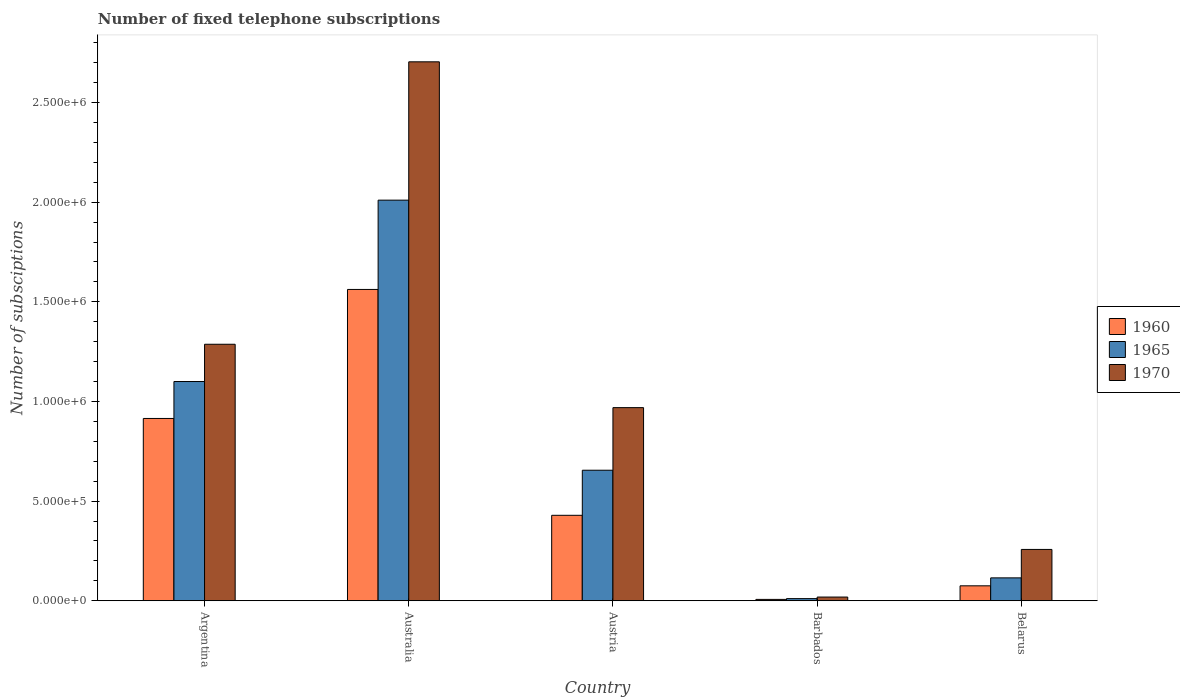How many different coloured bars are there?
Keep it short and to the point. 3. How many groups of bars are there?
Your response must be concise. 5. How many bars are there on the 1st tick from the right?
Make the answer very short. 3. What is the number of fixed telephone subscriptions in 1970 in Australia?
Keep it short and to the point. 2.70e+06. Across all countries, what is the maximum number of fixed telephone subscriptions in 1965?
Give a very brief answer. 2.01e+06. Across all countries, what is the minimum number of fixed telephone subscriptions in 1970?
Make the answer very short. 1.87e+04. In which country was the number of fixed telephone subscriptions in 1965 maximum?
Provide a succinct answer. Australia. In which country was the number of fixed telephone subscriptions in 1960 minimum?
Your answer should be compact. Barbados. What is the total number of fixed telephone subscriptions in 1970 in the graph?
Ensure brevity in your answer.  5.24e+06. What is the difference between the number of fixed telephone subscriptions in 1960 in Australia and that in Austria?
Your response must be concise. 1.13e+06. What is the difference between the number of fixed telephone subscriptions in 1970 in Austria and the number of fixed telephone subscriptions in 1965 in Australia?
Your answer should be compact. -1.04e+06. What is the average number of fixed telephone subscriptions in 1965 per country?
Offer a terse response. 7.78e+05. What is the difference between the number of fixed telephone subscriptions of/in 1965 and number of fixed telephone subscriptions of/in 1960 in Belarus?
Give a very brief answer. 3.99e+04. What is the ratio of the number of fixed telephone subscriptions in 1970 in Argentina to that in Barbados?
Your response must be concise. 68.89. Is the number of fixed telephone subscriptions in 1970 in Austria less than that in Barbados?
Make the answer very short. No. Is the difference between the number of fixed telephone subscriptions in 1965 in Barbados and Belarus greater than the difference between the number of fixed telephone subscriptions in 1960 in Barbados and Belarus?
Give a very brief answer. No. What is the difference between the highest and the second highest number of fixed telephone subscriptions in 1965?
Offer a terse response. 9.10e+05. What is the difference between the highest and the lowest number of fixed telephone subscriptions in 1960?
Your response must be concise. 1.56e+06. Is the sum of the number of fixed telephone subscriptions in 1965 in Argentina and Australia greater than the maximum number of fixed telephone subscriptions in 1960 across all countries?
Give a very brief answer. Yes. What does the 3rd bar from the left in Austria represents?
Offer a terse response. 1970. What does the 1st bar from the right in Argentina represents?
Give a very brief answer. 1970. Is it the case that in every country, the sum of the number of fixed telephone subscriptions in 1960 and number of fixed telephone subscriptions in 1970 is greater than the number of fixed telephone subscriptions in 1965?
Provide a short and direct response. Yes. Are all the bars in the graph horizontal?
Keep it short and to the point. No. Does the graph contain any zero values?
Your response must be concise. No. Where does the legend appear in the graph?
Your answer should be very brief. Center right. How many legend labels are there?
Provide a succinct answer. 3. How are the legend labels stacked?
Your answer should be very brief. Vertical. What is the title of the graph?
Provide a short and direct response. Number of fixed telephone subscriptions. Does "2006" appear as one of the legend labels in the graph?
Provide a succinct answer. No. What is the label or title of the X-axis?
Provide a succinct answer. Country. What is the label or title of the Y-axis?
Keep it short and to the point. Number of subsciptions. What is the Number of subsciptions in 1960 in Argentina?
Provide a short and direct response. 9.15e+05. What is the Number of subsciptions in 1965 in Argentina?
Your response must be concise. 1.10e+06. What is the Number of subsciptions of 1970 in Argentina?
Offer a terse response. 1.29e+06. What is the Number of subsciptions of 1960 in Australia?
Give a very brief answer. 1.56e+06. What is the Number of subsciptions of 1965 in Australia?
Your answer should be very brief. 2.01e+06. What is the Number of subsciptions of 1970 in Australia?
Your response must be concise. 2.70e+06. What is the Number of subsciptions in 1960 in Austria?
Offer a terse response. 4.29e+05. What is the Number of subsciptions in 1965 in Austria?
Provide a short and direct response. 6.55e+05. What is the Number of subsciptions in 1970 in Austria?
Offer a terse response. 9.69e+05. What is the Number of subsciptions of 1960 in Barbados?
Give a very brief answer. 6933. What is the Number of subsciptions of 1965 in Barbados?
Offer a very short reply. 1.08e+04. What is the Number of subsciptions in 1970 in Barbados?
Your answer should be very brief. 1.87e+04. What is the Number of subsciptions in 1960 in Belarus?
Your response must be concise. 7.50e+04. What is the Number of subsciptions of 1965 in Belarus?
Keep it short and to the point. 1.15e+05. What is the Number of subsciptions of 1970 in Belarus?
Your answer should be compact. 2.58e+05. Across all countries, what is the maximum Number of subsciptions of 1960?
Provide a succinct answer. 1.56e+06. Across all countries, what is the maximum Number of subsciptions of 1965?
Your answer should be very brief. 2.01e+06. Across all countries, what is the maximum Number of subsciptions of 1970?
Give a very brief answer. 2.70e+06. Across all countries, what is the minimum Number of subsciptions in 1960?
Provide a short and direct response. 6933. Across all countries, what is the minimum Number of subsciptions in 1965?
Provide a short and direct response. 1.08e+04. Across all countries, what is the minimum Number of subsciptions of 1970?
Offer a terse response. 1.87e+04. What is the total Number of subsciptions in 1960 in the graph?
Keep it short and to the point. 2.99e+06. What is the total Number of subsciptions in 1965 in the graph?
Provide a short and direct response. 3.89e+06. What is the total Number of subsciptions of 1970 in the graph?
Provide a short and direct response. 5.24e+06. What is the difference between the Number of subsciptions in 1960 in Argentina and that in Australia?
Make the answer very short. -6.47e+05. What is the difference between the Number of subsciptions of 1965 in Argentina and that in Australia?
Your answer should be very brief. -9.10e+05. What is the difference between the Number of subsciptions of 1970 in Argentina and that in Australia?
Give a very brief answer. -1.42e+06. What is the difference between the Number of subsciptions in 1960 in Argentina and that in Austria?
Give a very brief answer. 4.86e+05. What is the difference between the Number of subsciptions in 1965 in Argentina and that in Austria?
Ensure brevity in your answer.  4.45e+05. What is the difference between the Number of subsciptions of 1970 in Argentina and that in Austria?
Offer a very short reply. 3.18e+05. What is the difference between the Number of subsciptions of 1960 in Argentina and that in Barbados?
Keep it short and to the point. 9.08e+05. What is the difference between the Number of subsciptions of 1965 in Argentina and that in Barbados?
Give a very brief answer. 1.09e+06. What is the difference between the Number of subsciptions of 1970 in Argentina and that in Barbados?
Offer a terse response. 1.27e+06. What is the difference between the Number of subsciptions in 1960 in Argentina and that in Belarus?
Offer a terse response. 8.40e+05. What is the difference between the Number of subsciptions of 1965 in Argentina and that in Belarus?
Your answer should be very brief. 9.85e+05. What is the difference between the Number of subsciptions in 1970 in Argentina and that in Belarus?
Provide a short and direct response. 1.03e+06. What is the difference between the Number of subsciptions of 1960 in Australia and that in Austria?
Ensure brevity in your answer.  1.13e+06. What is the difference between the Number of subsciptions of 1965 in Australia and that in Austria?
Provide a short and direct response. 1.36e+06. What is the difference between the Number of subsciptions of 1970 in Australia and that in Austria?
Your answer should be very brief. 1.74e+06. What is the difference between the Number of subsciptions in 1960 in Australia and that in Barbados?
Provide a short and direct response. 1.56e+06. What is the difference between the Number of subsciptions of 1965 in Australia and that in Barbados?
Keep it short and to the point. 2.00e+06. What is the difference between the Number of subsciptions in 1970 in Australia and that in Barbados?
Your answer should be very brief. 2.69e+06. What is the difference between the Number of subsciptions of 1960 in Australia and that in Belarus?
Provide a succinct answer. 1.49e+06. What is the difference between the Number of subsciptions of 1965 in Australia and that in Belarus?
Offer a terse response. 1.90e+06. What is the difference between the Number of subsciptions in 1970 in Australia and that in Belarus?
Give a very brief answer. 2.45e+06. What is the difference between the Number of subsciptions of 1960 in Austria and that in Barbados?
Your response must be concise. 4.22e+05. What is the difference between the Number of subsciptions in 1965 in Austria and that in Barbados?
Give a very brief answer. 6.44e+05. What is the difference between the Number of subsciptions in 1970 in Austria and that in Barbados?
Keep it short and to the point. 9.50e+05. What is the difference between the Number of subsciptions of 1960 in Austria and that in Belarus?
Make the answer very short. 3.54e+05. What is the difference between the Number of subsciptions in 1965 in Austria and that in Belarus?
Make the answer very short. 5.40e+05. What is the difference between the Number of subsciptions in 1970 in Austria and that in Belarus?
Your response must be concise. 7.11e+05. What is the difference between the Number of subsciptions in 1960 in Barbados and that in Belarus?
Your answer should be compact. -6.81e+04. What is the difference between the Number of subsciptions in 1965 in Barbados and that in Belarus?
Make the answer very short. -1.04e+05. What is the difference between the Number of subsciptions of 1970 in Barbados and that in Belarus?
Make the answer very short. -2.39e+05. What is the difference between the Number of subsciptions of 1960 in Argentina and the Number of subsciptions of 1965 in Australia?
Your answer should be very brief. -1.10e+06. What is the difference between the Number of subsciptions of 1960 in Argentina and the Number of subsciptions of 1970 in Australia?
Provide a short and direct response. -1.79e+06. What is the difference between the Number of subsciptions of 1965 in Argentina and the Number of subsciptions of 1970 in Australia?
Provide a short and direct response. -1.60e+06. What is the difference between the Number of subsciptions of 1960 in Argentina and the Number of subsciptions of 1965 in Austria?
Your answer should be compact. 2.60e+05. What is the difference between the Number of subsciptions in 1960 in Argentina and the Number of subsciptions in 1970 in Austria?
Your answer should be compact. -5.43e+04. What is the difference between the Number of subsciptions in 1965 in Argentina and the Number of subsciptions in 1970 in Austria?
Ensure brevity in your answer.  1.31e+05. What is the difference between the Number of subsciptions of 1960 in Argentina and the Number of subsciptions of 1965 in Barbados?
Make the answer very short. 9.04e+05. What is the difference between the Number of subsciptions in 1960 in Argentina and the Number of subsciptions in 1970 in Barbados?
Make the answer very short. 8.96e+05. What is the difference between the Number of subsciptions in 1965 in Argentina and the Number of subsciptions in 1970 in Barbados?
Offer a terse response. 1.08e+06. What is the difference between the Number of subsciptions in 1960 in Argentina and the Number of subsciptions in 1965 in Belarus?
Make the answer very short. 8.00e+05. What is the difference between the Number of subsciptions of 1960 in Argentina and the Number of subsciptions of 1970 in Belarus?
Offer a terse response. 6.57e+05. What is the difference between the Number of subsciptions in 1965 in Argentina and the Number of subsciptions in 1970 in Belarus?
Offer a very short reply. 8.42e+05. What is the difference between the Number of subsciptions in 1960 in Australia and the Number of subsciptions in 1965 in Austria?
Your answer should be compact. 9.07e+05. What is the difference between the Number of subsciptions of 1960 in Australia and the Number of subsciptions of 1970 in Austria?
Your answer should be compact. 5.93e+05. What is the difference between the Number of subsciptions of 1965 in Australia and the Number of subsciptions of 1970 in Austria?
Provide a short and direct response. 1.04e+06. What is the difference between the Number of subsciptions in 1960 in Australia and the Number of subsciptions in 1965 in Barbados?
Make the answer very short. 1.55e+06. What is the difference between the Number of subsciptions of 1960 in Australia and the Number of subsciptions of 1970 in Barbados?
Offer a very short reply. 1.54e+06. What is the difference between the Number of subsciptions of 1965 in Australia and the Number of subsciptions of 1970 in Barbados?
Your answer should be compact. 1.99e+06. What is the difference between the Number of subsciptions in 1960 in Australia and the Number of subsciptions in 1965 in Belarus?
Ensure brevity in your answer.  1.45e+06. What is the difference between the Number of subsciptions in 1960 in Australia and the Number of subsciptions in 1970 in Belarus?
Keep it short and to the point. 1.30e+06. What is the difference between the Number of subsciptions in 1965 in Australia and the Number of subsciptions in 1970 in Belarus?
Offer a terse response. 1.75e+06. What is the difference between the Number of subsciptions in 1960 in Austria and the Number of subsciptions in 1965 in Barbados?
Ensure brevity in your answer.  4.18e+05. What is the difference between the Number of subsciptions of 1960 in Austria and the Number of subsciptions of 1970 in Barbados?
Ensure brevity in your answer.  4.10e+05. What is the difference between the Number of subsciptions of 1965 in Austria and the Number of subsciptions of 1970 in Barbados?
Provide a succinct answer. 6.36e+05. What is the difference between the Number of subsciptions of 1960 in Austria and the Number of subsciptions of 1965 in Belarus?
Offer a very short reply. 3.14e+05. What is the difference between the Number of subsciptions of 1960 in Austria and the Number of subsciptions of 1970 in Belarus?
Your answer should be very brief. 1.71e+05. What is the difference between the Number of subsciptions of 1965 in Austria and the Number of subsciptions of 1970 in Belarus?
Ensure brevity in your answer.  3.97e+05. What is the difference between the Number of subsciptions of 1960 in Barbados and the Number of subsciptions of 1965 in Belarus?
Give a very brief answer. -1.08e+05. What is the difference between the Number of subsciptions in 1960 in Barbados and the Number of subsciptions in 1970 in Belarus?
Make the answer very short. -2.51e+05. What is the difference between the Number of subsciptions in 1965 in Barbados and the Number of subsciptions in 1970 in Belarus?
Provide a succinct answer. -2.47e+05. What is the average Number of subsciptions in 1960 per country?
Provide a short and direct response. 5.97e+05. What is the average Number of subsciptions in 1965 per country?
Your answer should be compact. 7.78e+05. What is the average Number of subsciptions of 1970 per country?
Your answer should be compact. 1.05e+06. What is the difference between the Number of subsciptions of 1960 and Number of subsciptions of 1965 in Argentina?
Your answer should be very brief. -1.85e+05. What is the difference between the Number of subsciptions in 1960 and Number of subsciptions in 1970 in Argentina?
Keep it short and to the point. -3.72e+05. What is the difference between the Number of subsciptions in 1965 and Number of subsciptions in 1970 in Argentina?
Your answer should be very brief. -1.87e+05. What is the difference between the Number of subsciptions in 1960 and Number of subsciptions in 1965 in Australia?
Keep it short and to the point. -4.48e+05. What is the difference between the Number of subsciptions of 1960 and Number of subsciptions of 1970 in Australia?
Ensure brevity in your answer.  -1.14e+06. What is the difference between the Number of subsciptions in 1965 and Number of subsciptions in 1970 in Australia?
Make the answer very short. -6.94e+05. What is the difference between the Number of subsciptions in 1960 and Number of subsciptions in 1965 in Austria?
Provide a succinct answer. -2.26e+05. What is the difference between the Number of subsciptions of 1960 and Number of subsciptions of 1970 in Austria?
Keep it short and to the point. -5.40e+05. What is the difference between the Number of subsciptions of 1965 and Number of subsciptions of 1970 in Austria?
Provide a succinct answer. -3.14e+05. What is the difference between the Number of subsciptions of 1960 and Number of subsciptions of 1965 in Barbados?
Give a very brief answer. -3868. What is the difference between the Number of subsciptions of 1960 and Number of subsciptions of 1970 in Barbados?
Ensure brevity in your answer.  -1.17e+04. What is the difference between the Number of subsciptions in 1965 and Number of subsciptions in 1970 in Barbados?
Ensure brevity in your answer.  -7881. What is the difference between the Number of subsciptions in 1960 and Number of subsciptions in 1965 in Belarus?
Keep it short and to the point. -3.99e+04. What is the difference between the Number of subsciptions in 1960 and Number of subsciptions in 1970 in Belarus?
Provide a short and direct response. -1.83e+05. What is the difference between the Number of subsciptions in 1965 and Number of subsciptions in 1970 in Belarus?
Ensure brevity in your answer.  -1.43e+05. What is the ratio of the Number of subsciptions in 1960 in Argentina to that in Australia?
Keep it short and to the point. 0.59. What is the ratio of the Number of subsciptions of 1965 in Argentina to that in Australia?
Keep it short and to the point. 0.55. What is the ratio of the Number of subsciptions of 1970 in Argentina to that in Australia?
Give a very brief answer. 0.48. What is the ratio of the Number of subsciptions in 1960 in Argentina to that in Austria?
Offer a very short reply. 2.13. What is the ratio of the Number of subsciptions of 1965 in Argentina to that in Austria?
Provide a short and direct response. 1.68. What is the ratio of the Number of subsciptions in 1970 in Argentina to that in Austria?
Provide a short and direct response. 1.33. What is the ratio of the Number of subsciptions of 1960 in Argentina to that in Barbados?
Give a very brief answer. 131.93. What is the ratio of the Number of subsciptions in 1965 in Argentina to that in Barbados?
Your response must be concise. 101.84. What is the ratio of the Number of subsciptions in 1970 in Argentina to that in Barbados?
Provide a succinct answer. 68.89. What is the ratio of the Number of subsciptions in 1960 in Argentina to that in Belarus?
Offer a terse response. 12.2. What is the ratio of the Number of subsciptions in 1965 in Argentina to that in Belarus?
Make the answer very short. 9.57. What is the ratio of the Number of subsciptions of 1970 in Argentina to that in Belarus?
Keep it short and to the point. 5. What is the ratio of the Number of subsciptions in 1960 in Australia to that in Austria?
Provide a succinct answer. 3.64. What is the ratio of the Number of subsciptions in 1965 in Australia to that in Austria?
Your response must be concise. 3.07. What is the ratio of the Number of subsciptions of 1970 in Australia to that in Austria?
Offer a very short reply. 2.79. What is the ratio of the Number of subsciptions of 1960 in Australia to that in Barbados?
Offer a terse response. 225.29. What is the ratio of the Number of subsciptions of 1965 in Australia to that in Barbados?
Ensure brevity in your answer.  186.09. What is the ratio of the Number of subsciptions of 1970 in Australia to that in Barbados?
Your answer should be very brief. 144.74. What is the ratio of the Number of subsciptions of 1960 in Australia to that in Belarus?
Provide a succinct answer. 20.83. What is the ratio of the Number of subsciptions of 1965 in Australia to that in Belarus?
Offer a terse response. 17.49. What is the ratio of the Number of subsciptions in 1970 in Australia to that in Belarus?
Ensure brevity in your answer.  10.5. What is the ratio of the Number of subsciptions of 1960 in Austria to that in Barbados?
Keep it short and to the point. 61.85. What is the ratio of the Number of subsciptions of 1965 in Austria to that in Barbados?
Provide a succinct answer. 60.64. What is the ratio of the Number of subsciptions of 1970 in Austria to that in Barbados?
Your answer should be very brief. 51.87. What is the ratio of the Number of subsciptions in 1960 in Austria to that in Belarus?
Make the answer very short. 5.72. What is the ratio of the Number of subsciptions of 1965 in Austria to that in Belarus?
Keep it short and to the point. 5.7. What is the ratio of the Number of subsciptions in 1970 in Austria to that in Belarus?
Offer a very short reply. 3.76. What is the ratio of the Number of subsciptions of 1960 in Barbados to that in Belarus?
Provide a succinct answer. 0.09. What is the ratio of the Number of subsciptions of 1965 in Barbados to that in Belarus?
Offer a very short reply. 0.09. What is the ratio of the Number of subsciptions in 1970 in Barbados to that in Belarus?
Offer a terse response. 0.07. What is the difference between the highest and the second highest Number of subsciptions of 1960?
Provide a succinct answer. 6.47e+05. What is the difference between the highest and the second highest Number of subsciptions of 1965?
Offer a terse response. 9.10e+05. What is the difference between the highest and the second highest Number of subsciptions of 1970?
Your answer should be compact. 1.42e+06. What is the difference between the highest and the lowest Number of subsciptions in 1960?
Ensure brevity in your answer.  1.56e+06. What is the difference between the highest and the lowest Number of subsciptions of 1965?
Make the answer very short. 2.00e+06. What is the difference between the highest and the lowest Number of subsciptions of 1970?
Your answer should be compact. 2.69e+06. 